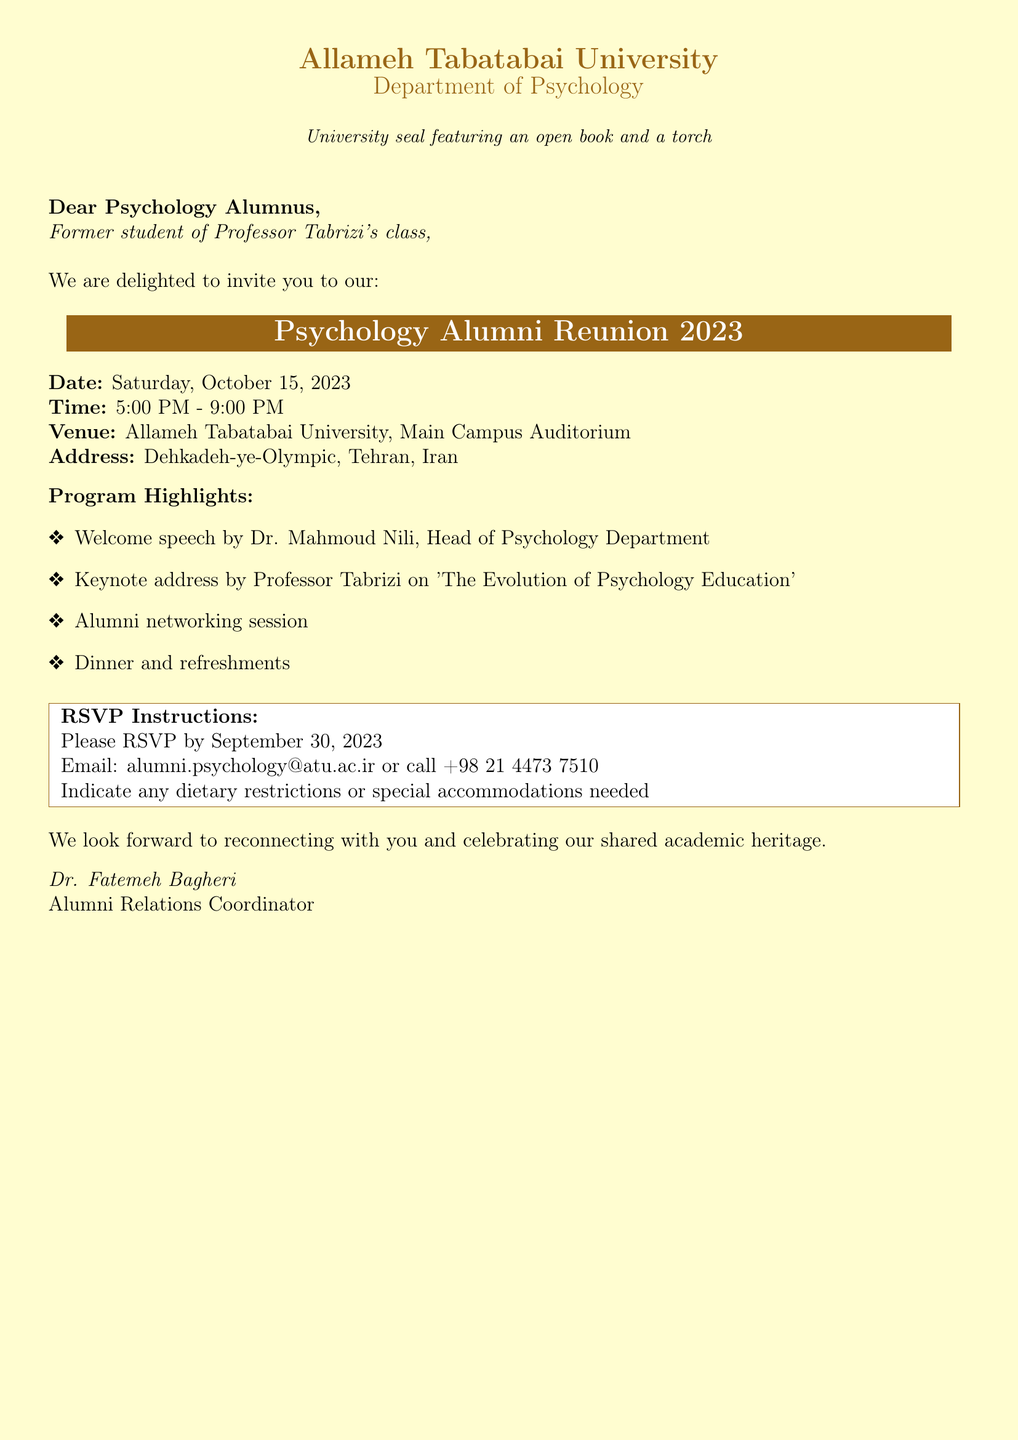What is the date of the reunion? The document specifies that the reunion will take place on Saturday, October 15, 2023.
Answer: Saturday, October 15, 2023 Who will give the keynote address? According to the document, Professor Tabrizi will give the keynote address on 'The Evolution of Psychology Education.'
Answer: Professor Tabrizi What time does the reunion start? The document states that the reunion will start at 5:00 PM.
Answer: 5:00 PM What is the venue of the event? The document indicates that the reunion will be held at Allameh Tabatabai University, Main Campus Auditorium.
Answer: Allameh Tabatabai University, Main Campus Auditorium What is the RSVP deadline? The document mentions that attendees must RSVP by September 30, 2023.
Answer: September 30, 2023 What should attendees indicate in their RSVP? The document requests attendees to indicate any dietary restrictions or special accommodations needed.
Answer: Dietary restrictions or special accommodations Who is the Alumni Relations Coordinator? The document identifies Dr. Fatemeh Bagheri as the Alumni Relations Coordinator.
Answer: Dr. Fatemeh Bagheri What will be provided during the reunion? The document lists dinner and refreshments as part of the program highlights.
Answer: Dinner and refreshments What is the contact email for RSVP? The document provides the email alumni.psychology@atu.ac.ir for RSVPs.
Answer: alumni.psychology@atu.ac.ir 